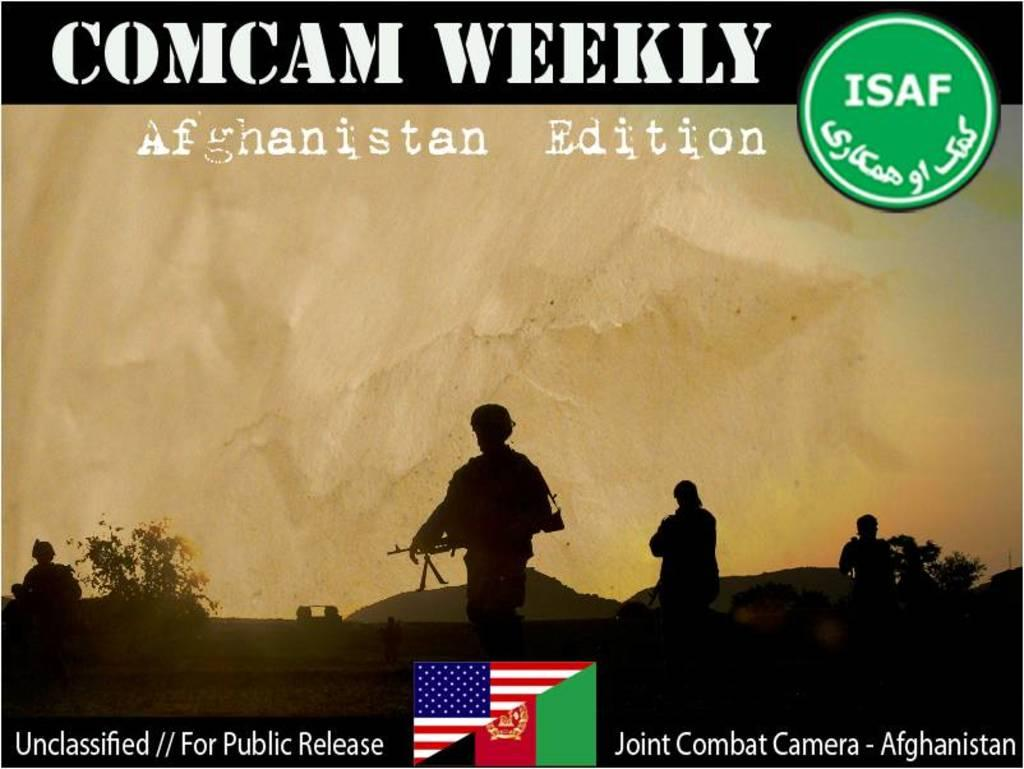<image>
Summarize the visual content of the image. An advertisement for Comcam Weekly Afganistan Edition featuring silhouettes of soldiers. 